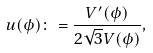<formula> <loc_0><loc_0><loc_500><loc_500>u ( \phi ) \colon = \frac { V ^ { \prime } ( \phi ) } { 2 \sqrt { 3 } V ( \phi ) } ,</formula> 